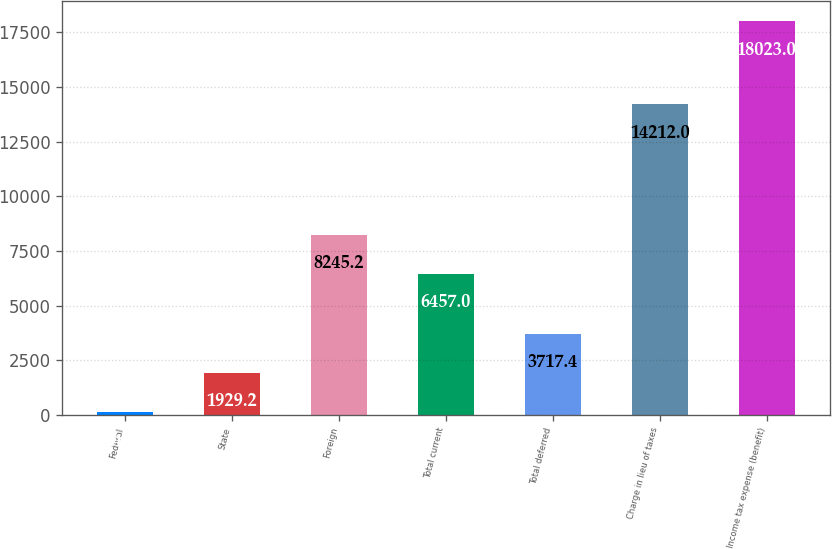<chart> <loc_0><loc_0><loc_500><loc_500><bar_chart><fcel>Federal<fcel>State<fcel>Foreign<fcel>Total current<fcel>Total deferred<fcel>Charge in lieu of taxes<fcel>Income tax expense (benefit)<nl><fcel>141<fcel>1929.2<fcel>8245.2<fcel>6457<fcel>3717.4<fcel>14212<fcel>18023<nl></chart> 